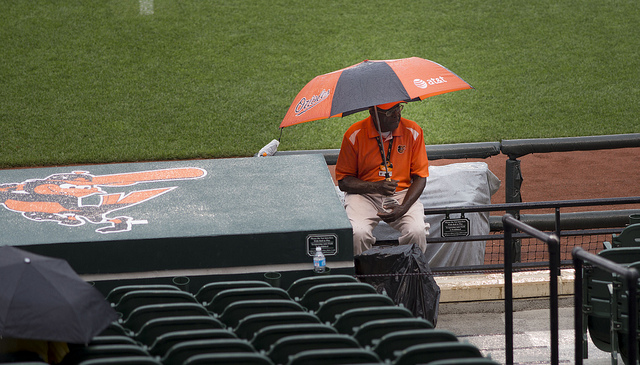<image>What color is the umpire's seat? I am not sure what color the umpire's seat is. It could be black, green, or gray. What color is the umpire's seat? I don't know what color the umpire's seat is. It can be seen as black, green, gray, or none. 